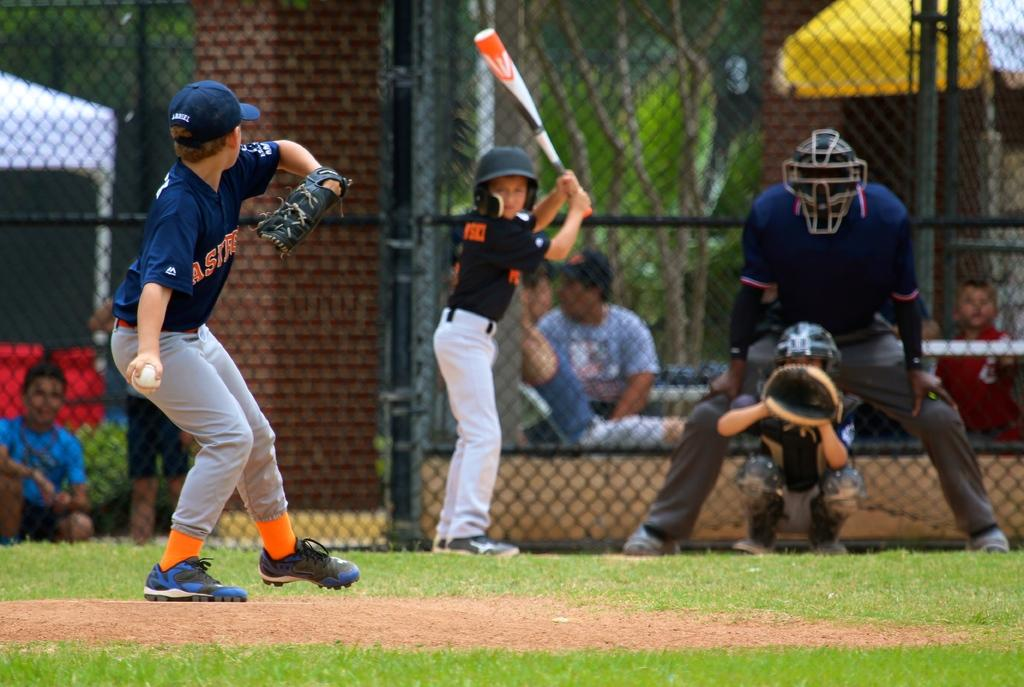Provide a one-sentence caption for the provided image. An Astros pitcher throws a pitch to a batter. 